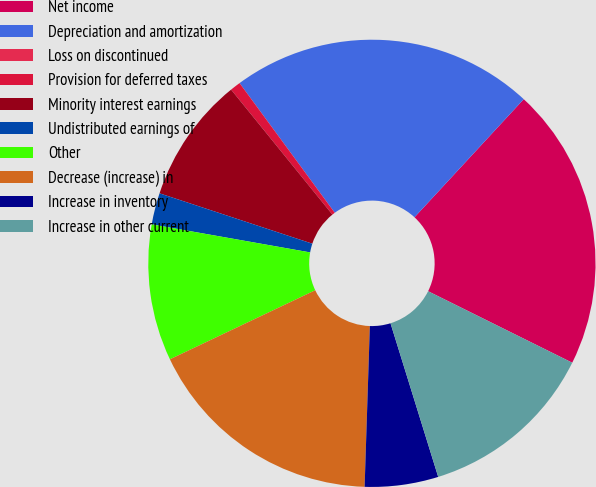Convert chart to OTSL. <chart><loc_0><loc_0><loc_500><loc_500><pie_chart><fcel>Net income<fcel>Depreciation and amortization<fcel>Loss on discontinued<fcel>Provision for deferred taxes<fcel>Minority interest earnings<fcel>Undistributed earnings of<fcel>Other<fcel>Decrease (increase) in<fcel>Increase in inventory<fcel>Increase in other current<nl><fcel>20.45%<fcel>21.96%<fcel>0.0%<fcel>0.76%<fcel>9.09%<fcel>2.28%<fcel>9.85%<fcel>17.42%<fcel>5.31%<fcel>12.88%<nl></chart> 